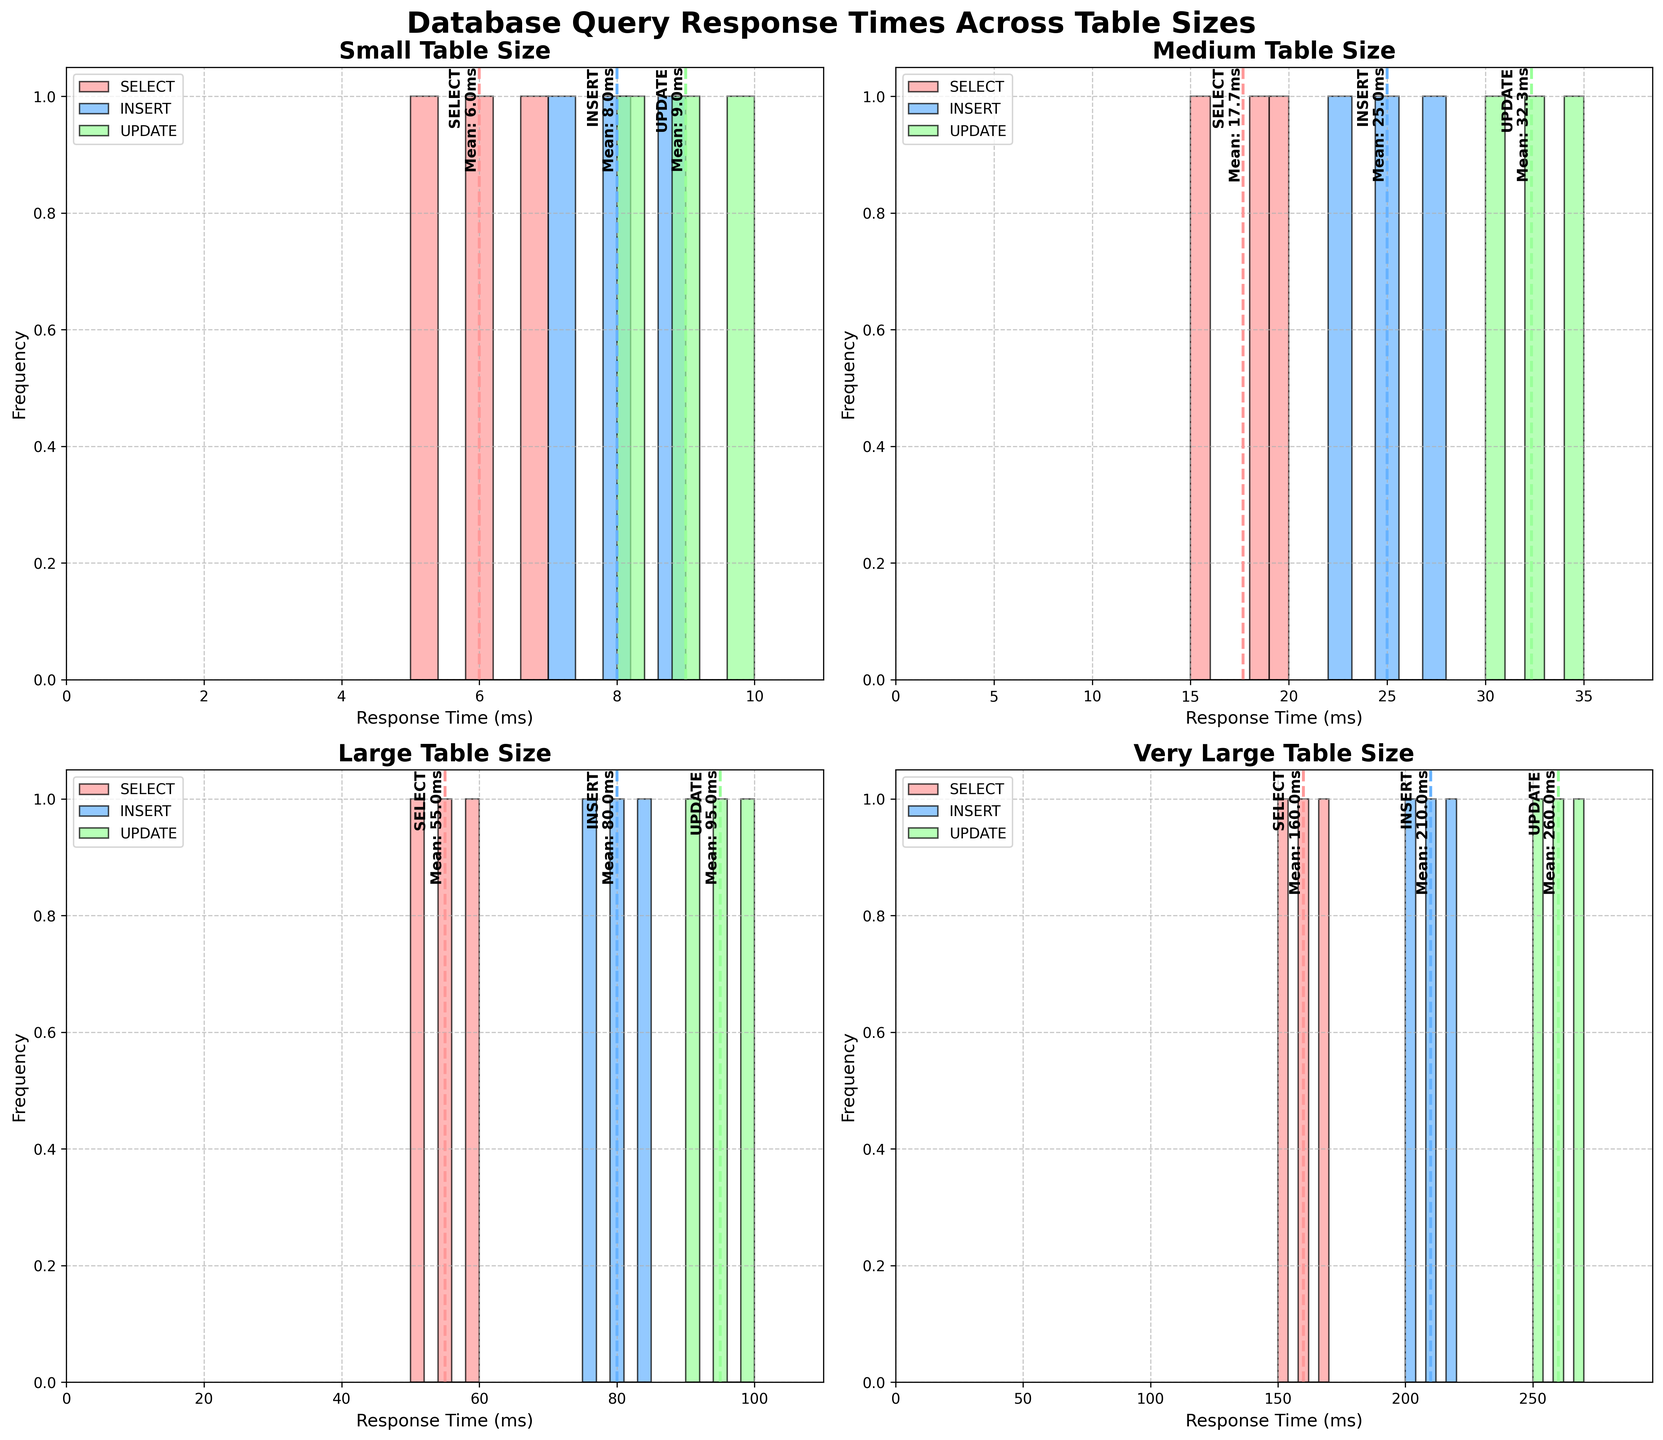What does the title of the figure say? The title is found at the top center of the figure and it summarizes the overall content of the plot. The title helps identify what the data represents.
Answer: Database Query Response Times Across Table Sizes How many subplots are there and what do they represent? There are four subplots, arranged in a 2x2 grid. Each subplot represents a different table size: Small, Medium, Large, and Very Large.
Answer: Four subplots representing Small, Medium, Large, and Very Large table sizes What color represents the 'INSERT' query type? The color defined for the 'INSERT' query type is consistent across all subplots. By checking the legend or the corresponding bars in the histogram, we can determine the color.
Answer: Blue Which table size shows the largest range of response times for 'SELECT' queries? The range of response times can be determined by looking at the spread of the histogram bars for 'SELECT' queries in each subplot. The 'Very Large' table size shows the widest spread for 'SELECT' queries (from 150ms to 170ms).
Answer: Very Large What is the average response time for 'UPDATE' queries in the 'Medium' table size? By looking at the dashed mean lines in the 'Medium' table size subplot, we can identify the average response time. The line corresponding to the 'UPDATE' query type will show this value. For 'Medium' table sizes, it is approximately 32.3ms.
Answer: 32.3ms Between 'Small' and 'Medium' table sizes, which has a higher average response time for 'INSERT' queries? We need to compare the mean lines for 'INSERT' queries in the 'Small' and 'Medium' subplots. The mean line in the 'Small' subplot is around 8ms, while in the 'Medium' subplot it is around 25ms. Thus, the 'Medium' table size has a higher average.
Answer: Medium How does the frequency distribution of 'SELECT' queries in the 'Large' table size compare to that in the 'Very Large' table size? We compare the distribution of bars for 'SELECT' queries in both 'Large' and 'Very Large' subplots. 'Large' has a tighter distribution between 50ms and 60ms, while 'Very Large' has a broader distribution between 150ms and 170ms.
Answer: 'Very Large' is broader and at higher response times What can you infer about the response times of 'UPDATE' queries as table sizes increase from 'Small' to 'Very Large'? By examining the histograms and mean lines across the subplots for 'UPDATE' queries, we see a trend of increasing mean response times: 'Small' (around 9ms), 'Medium' (around 32.3ms), 'Large' (around 95ms), and 'Very Large' (around 260ms).
Answer: Response times increase with table size Which query type tends to have higher response times in 'Large' tables? By observing the bars and mean lines for 'Large' tables, 'UPDATE' queries show higher response times (up to 100ms) compared to 'SELECT' (up to 60ms) and 'INSERT' (up to 85ms).
Answer: UPDATE 